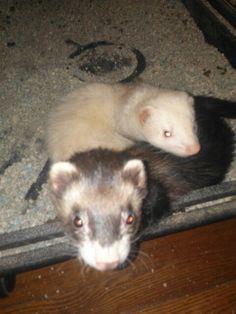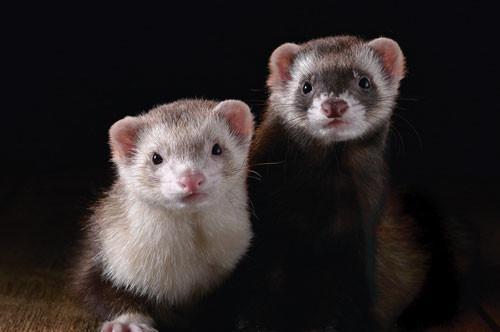The first image is the image on the left, the second image is the image on the right. Given the left and right images, does the statement "Someone is holding at least one of the animals." hold true? Answer yes or no. No. 